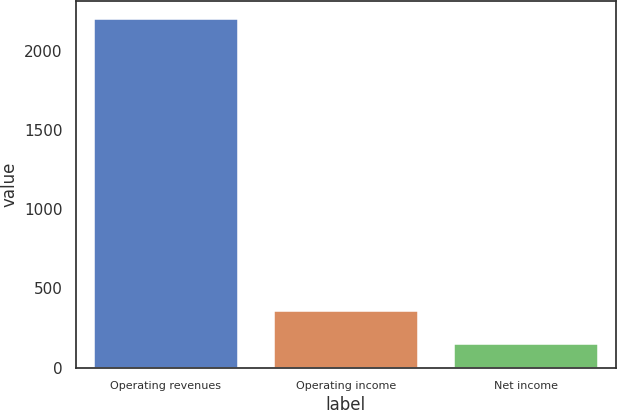Convert chart to OTSL. <chart><loc_0><loc_0><loc_500><loc_500><bar_chart><fcel>Operating revenues<fcel>Operating income<fcel>Net income<nl><fcel>2206<fcel>358<fcel>149<nl></chart> 